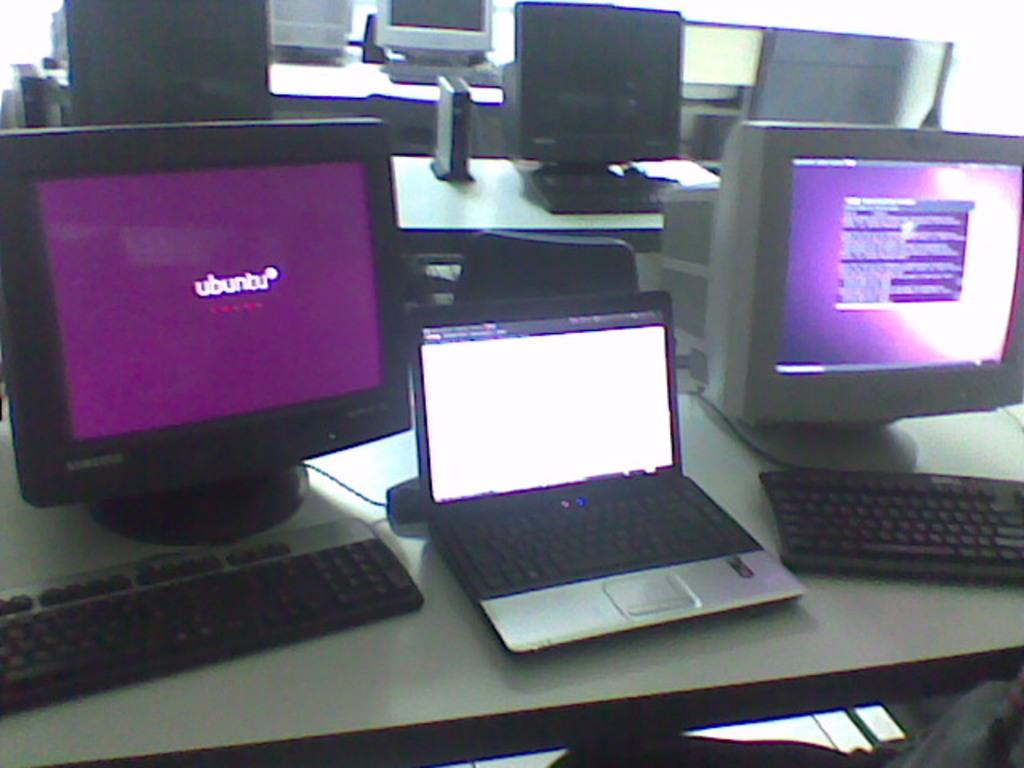<image>
Provide a brief description of the given image. A Samsung desktop computer displays the logo for ubunbu. 